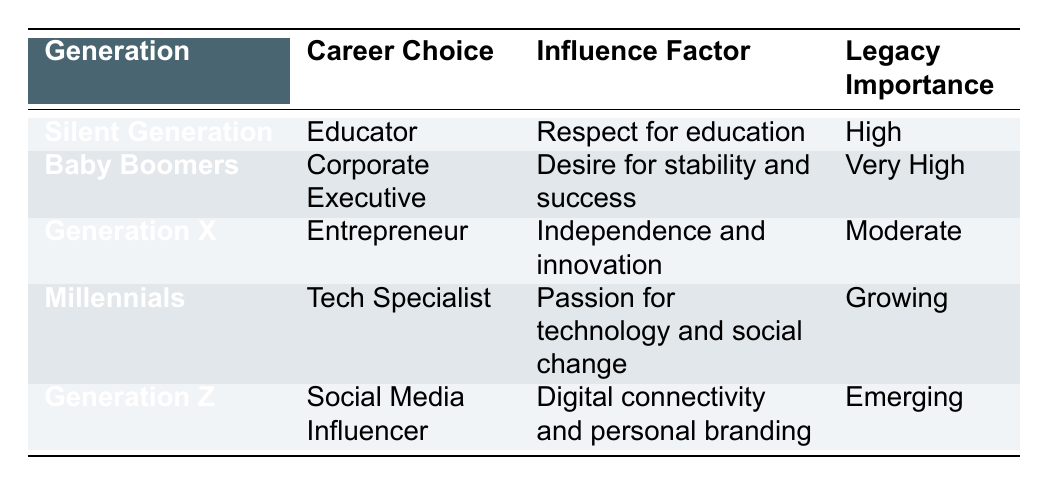What is the career choice for the Baby Boomers? The Baby Boomers' career choice as listed in the table is "Corporate Executive." This information is retrieved directly from the respective row concerning the Baby Boomers.
Answer: Corporate Executive Which generation has a career choice labeled 'Entrepreneur'? The generation with a career choice labeled 'Entrepreneur' is Generation X. This is identified by locating 'Entrepreneur' in the Career Choice column and referring to the corresponding generation.
Answer: Generation X What is the legacy importance for Millennials? The legacy importance associated with Millennials in the table is "Growing." This is obtained by referencing the relevant row for Millennials in the Legacy Importance column.
Answer: Growing Is the legacy importance for the Silent Generation considered 'Very High'? No, the legacy importance for the Silent Generation is labeled as 'High,' not 'Very High.' Analyzing the respective row reveals that its legacy importance is lower than 'Very High.'
Answer: No Which generation has the highest legacy importance? The generation with the highest legacy importance is the Baby Boomers, with a rating of 'Very High.' This is established by comparing the legacy importance values across all generations listed in the table.
Answer: Baby Boomers How many generations have a legacy importance labeled as 'Emerging'? There is one generation with a legacy importance labeled as 'Emerging,' which is Generation Z. This is found by scanning through the Legacy Importance column to identify counts of 'Emerging.'
Answer: 1 Which career choice has the influence factor of 'Passion for technology and social change'? The career choice that has the influence factor of 'Passion for technology and social change' is 'Tech Specialist,' which corresponds to the Millennials. This is found by cross-referencing the influence factor with its associated career choice in the table.
Answer: Tech Specialist What is the influence factor for the Silent Generation and how does it compare to that of Generation X? The influence factor for the Silent Generation is 'Respect for education,' while for Generation X, it is 'Independence and innovation.' Comparing these feeds different values as both relate to distinct generational perspectives but do not exhibit a numerical comparison.
Answer: Not comparable Which generation is most likely to be influenced by digital connectivity? Generation Z is the generation most likely to be influenced by digital connectivity, as indicated by its career choice of 'Social Media Influencer' and corresponding influence factor. This is derived from examining the influence factors listed in relation to their career choices.
Answer: Generation Z 